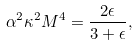<formula> <loc_0><loc_0><loc_500><loc_500>\alpha ^ { 2 } \kappa ^ { 2 } M ^ { 4 } = \frac { 2 \epsilon } { 3 + \epsilon } ,</formula> 